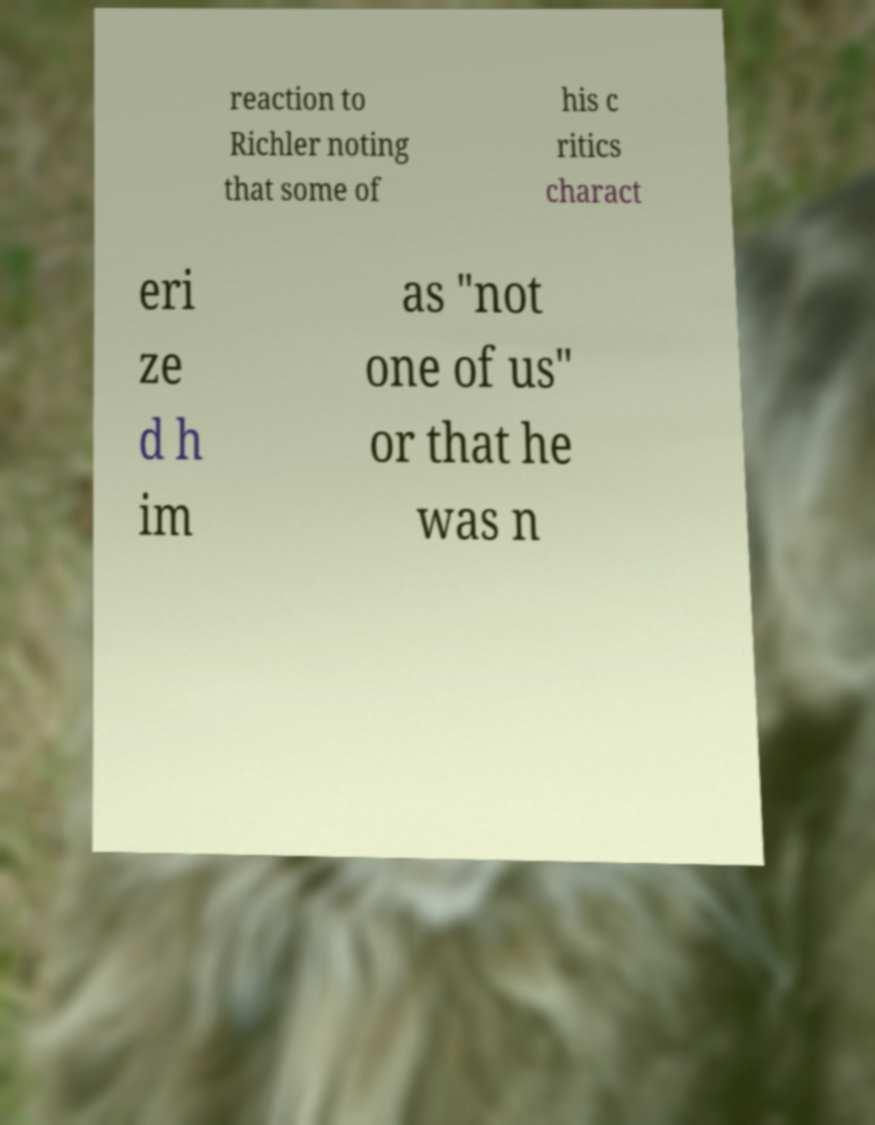Please identify and transcribe the text found in this image. reaction to Richler noting that some of his c ritics charact eri ze d h im as "not one of us" or that he was n 